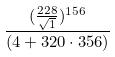<formula> <loc_0><loc_0><loc_500><loc_500>\frac { ( \frac { 2 2 8 } { \sqrt { 1 } } ) ^ { 1 5 6 } } { ( 4 + 3 2 0 \cdot 3 5 6 ) }</formula> 